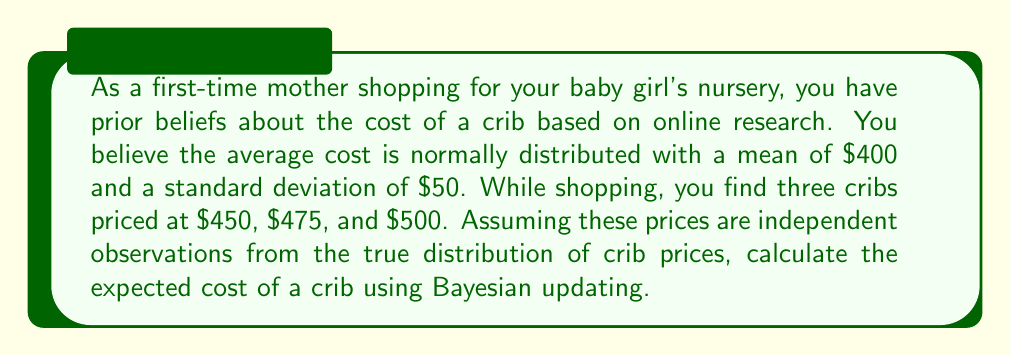Solve this math problem. To solve this problem, we'll use Bayesian updating with a normal prior and normal likelihood. The steps are as follows:

1. Define the prior distribution:
   $\mu_0 = 400$, $\sigma_0 = 50$

2. Calculate the sample mean of the observed prices:
   $\bar{x} = \frac{450 + 475 + 500}{3} = 475$

3. Define the likelihood:
   We assume the observed prices are from a normal distribution with unknown mean and known standard deviation. We'll use the sample standard deviation of the observed prices as an estimate:
   $s = \sqrt{\frac{(450-475)^2 + (475-475)^2 + (500-475)^2}{3-1}} \approx 25$

4. Apply Bayesian updating formula for normal distributions:
   $$\mu_n = \frac{\frac{\mu_0}{\sigma_0^2} + \frac{n\bar{x}}{s^2}}{\frac{1}{\sigma_0^2} + \frac{n}{s^2}}$$
   $$\sigma_n^2 = \frac{1}{\frac{1}{\sigma_0^2} + \frac{n}{s^2}}$$

   Where $n = 3$ (number of observations)

5. Calculate the posterior mean:
   $$\mu_n = \frac{\frac{400}{50^2} + \frac{3 \cdot 475}{25^2}}{\frac{1}{50^2} + \frac{3}{25^2}} \approx 456.25$$

6. Calculate the posterior standard deviation:
   $$\sigma_n^2 = \frac{1}{\frac{1}{50^2} + \frac{3}{25^2}} \approx 156.25$$
   $$\sigma_n = \sqrt{156.25} \approx 12.5$$

The expected cost of a crib, which is the posterior mean, is approximately $456.25.
Answer: $456.25 